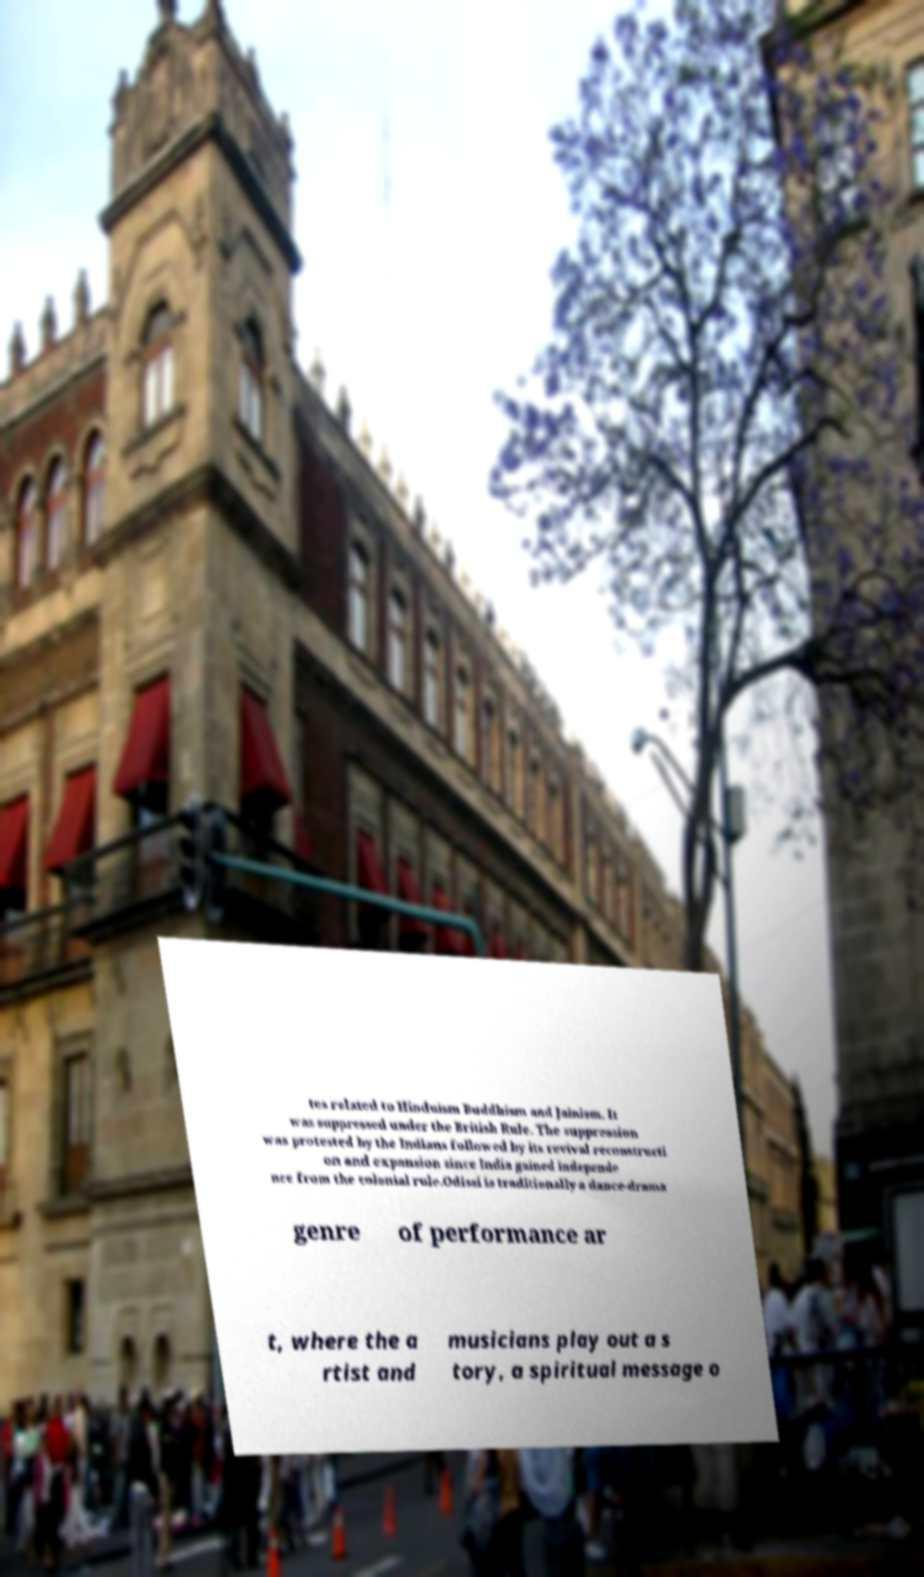Can you accurately transcribe the text from the provided image for me? tes related to Hinduism Buddhism and Jainism. It was suppressed under the British Rule. The suppression was protested by the Indians followed by its revival reconstructi on and expansion since India gained independe nce from the colonial rule.Odissi is traditionally a dance-drama genre of performance ar t, where the a rtist and musicians play out a s tory, a spiritual message o 